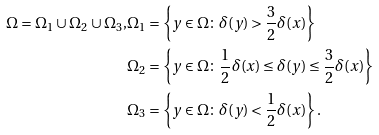<formula> <loc_0><loc_0><loc_500><loc_500>\Omega = \Omega _ { 1 } \cup \Omega _ { 2 } \cup \Omega _ { 3 } , & \Omega _ { 1 } = \left \{ y \in \Omega \colon \delta ( y ) > \frac { 3 } { 2 } \delta ( x ) \right \} \\ & \Omega _ { 2 } = \left \{ y \in \Omega \colon \frac { 1 } { 2 } \delta ( x ) \leq \delta ( y ) \leq \frac { 3 } { 2 } \delta ( x ) \right \} \\ & \Omega _ { 3 } = \left \{ y \in \Omega \colon \delta ( y ) < \frac { 1 } { 2 } \delta ( x ) \right \} .</formula> 